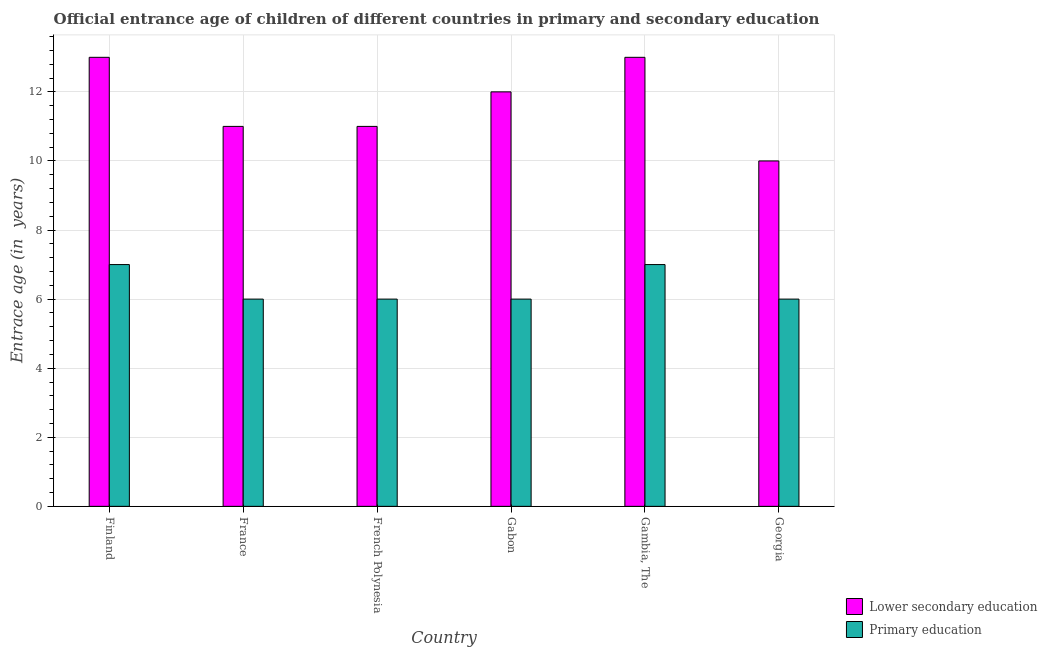How many different coloured bars are there?
Give a very brief answer. 2. How many groups of bars are there?
Offer a terse response. 6. How many bars are there on the 6th tick from the right?
Give a very brief answer. 2. What is the label of the 6th group of bars from the left?
Your answer should be very brief. Georgia. In how many cases, is the number of bars for a given country not equal to the number of legend labels?
Make the answer very short. 0. What is the entrance age of chiildren in primary education in French Polynesia?
Give a very brief answer. 6. Across all countries, what is the maximum entrance age of children in lower secondary education?
Your response must be concise. 13. Across all countries, what is the minimum entrance age of children in lower secondary education?
Provide a short and direct response. 10. In which country was the entrance age of children in lower secondary education maximum?
Provide a succinct answer. Finland. In which country was the entrance age of chiildren in primary education minimum?
Offer a terse response. France. What is the total entrance age of chiildren in primary education in the graph?
Provide a succinct answer. 38. What is the difference between the entrance age of children in lower secondary education in France and that in Gabon?
Give a very brief answer. -1. What is the difference between the entrance age of chiildren in primary education in French Polynesia and the entrance age of children in lower secondary education in Gabon?
Provide a succinct answer. -6. What is the average entrance age of chiildren in primary education per country?
Make the answer very short. 6.33. What is the difference between the entrance age of chiildren in primary education and entrance age of children in lower secondary education in Gabon?
Ensure brevity in your answer.  -6. In how many countries, is the entrance age of children in lower secondary education greater than 2.8 years?
Offer a very short reply. 6. What is the ratio of the entrance age of chiildren in primary education in Gabon to that in Gambia, The?
Offer a very short reply. 0.86. Is the entrance age of chiildren in primary education in Gabon less than that in Georgia?
Give a very brief answer. No. Is the difference between the entrance age of chiildren in primary education in Finland and Gambia, The greater than the difference between the entrance age of children in lower secondary education in Finland and Gambia, The?
Ensure brevity in your answer.  No. What is the difference between the highest and the second highest entrance age of children in lower secondary education?
Your answer should be very brief. 0. What is the difference between the highest and the lowest entrance age of children in lower secondary education?
Your answer should be compact. 3. In how many countries, is the entrance age of chiildren in primary education greater than the average entrance age of chiildren in primary education taken over all countries?
Make the answer very short. 2. Is the sum of the entrance age of children in lower secondary education in Gambia, The and Georgia greater than the maximum entrance age of chiildren in primary education across all countries?
Give a very brief answer. Yes. What does the 1st bar from the left in Finland represents?
Make the answer very short. Lower secondary education. What does the 2nd bar from the right in France represents?
Ensure brevity in your answer.  Lower secondary education. Are all the bars in the graph horizontal?
Keep it short and to the point. No. How many countries are there in the graph?
Your answer should be compact. 6. Does the graph contain any zero values?
Make the answer very short. No. Where does the legend appear in the graph?
Ensure brevity in your answer.  Bottom right. How many legend labels are there?
Your answer should be very brief. 2. How are the legend labels stacked?
Your response must be concise. Vertical. What is the title of the graph?
Provide a succinct answer. Official entrance age of children of different countries in primary and secondary education. What is the label or title of the Y-axis?
Offer a very short reply. Entrace age (in  years). What is the Entrace age (in  years) in Lower secondary education in Finland?
Provide a succinct answer. 13. What is the Entrace age (in  years) in Primary education in Finland?
Provide a short and direct response. 7. What is the Entrace age (in  years) in Lower secondary education in France?
Ensure brevity in your answer.  11. What is the Entrace age (in  years) of Lower secondary education in French Polynesia?
Offer a terse response. 11. What is the Entrace age (in  years) of Lower secondary education in Gabon?
Keep it short and to the point. 12. What is the Entrace age (in  years) of Primary education in Gabon?
Your answer should be compact. 6. What is the Entrace age (in  years) of Primary education in Gambia, The?
Ensure brevity in your answer.  7. What is the Entrace age (in  years) in Lower secondary education in Georgia?
Give a very brief answer. 10. What is the Entrace age (in  years) in Primary education in Georgia?
Offer a terse response. 6. Across all countries, what is the maximum Entrace age (in  years) in Lower secondary education?
Ensure brevity in your answer.  13. Across all countries, what is the maximum Entrace age (in  years) in Primary education?
Offer a terse response. 7. Across all countries, what is the minimum Entrace age (in  years) in Lower secondary education?
Provide a short and direct response. 10. Across all countries, what is the minimum Entrace age (in  years) in Primary education?
Ensure brevity in your answer.  6. What is the total Entrace age (in  years) in Lower secondary education in the graph?
Your answer should be compact. 70. What is the difference between the Entrace age (in  years) of Lower secondary education in Finland and that in France?
Offer a terse response. 2. What is the difference between the Entrace age (in  years) in Primary education in Finland and that in France?
Offer a terse response. 1. What is the difference between the Entrace age (in  years) of Lower secondary education in Finland and that in French Polynesia?
Provide a succinct answer. 2. What is the difference between the Entrace age (in  years) in Lower secondary education in Finland and that in Gabon?
Give a very brief answer. 1. What is the difference between the Entrace age (in  years) of Lower secondary education in Finland and that in Georgia?
Your answer should be compact. 3. What is the difference between the Entrace age (in  years) in Primary education in France and that in French Polynesia?
Offer a very short reply. 0. What is the difference between the Entrace age (in  years) in Lower secondary education in France and that in Gabon?
Your answer should be very brief. -1. What is the difference between the Entrace age (in  years) of Primary education in France and that in Gabon?
Ensure brevity in your answer.  0. What is the difference between the Entrace age (in  years) of Lower secondary education in France and that in Gambia, The?
Provide a succinct answer. -2. What is the difference between the Entrace age (in  years) of Primary education in France and that in Gambia, The?
Provide a succinct answer. -1. What is the difference between the Entrace age (in  years) of Lower secondary education in France and that in Georgia?
Provide a succinct answer. 1. What is the difference between the Entrace age (in  years) in Lower secondary education in French Polynesia and that in Gabon?
Keep it short and to the point. -1. What is the difference between the Entrace age (in  years) in Primary education in French Polynesia and that in Gabon?
Your response must be concise. 0. What is the difference between the Entrace age (in  years) of Lower secondary education in French Polynesia and that in Gambia, The?
Offer a terse response. -2. What is the difference between the Entrace age (in  years) in Primary education in French Polynesia and that in Gambia, The?
Your answer should be compact. -1. What is the difference between the Entrace age (in  years) of Primary education in French Polynesia and that in Georgia?
Your answer should be compact. 0. What is the difference between the Entrace age (in  years) in Lower secondary education in Gabon and that in Georgia?
Your answer should be compact. 2. What is the difference between the Entrace age (in  years) in Primary education in Gambia, The and that in Georgia?
Keep it short and to the point. 1. What is the difference between the Entrace age (in  years) in Lower secondary education in Finland and the Entrace age (in  years) in Primary education in France?
Give a very brief answer. 7. What is the difference between the Entrace age (in  years) of Lower secondary education in Finland and the Entrace age (in  years) of Primary education in French Polynesia?
Ensure brevity in your answer.  7. What is the difference between the Entrace age (in  years) in Lower secondary education in Finland and the Entrace age (in  years) in Primary education in Gabon?
Provide a succinct answer. 7. What is the difference between the Entrace age (in  years) in Lower secondary education in France and the Entrace age (in  years) in Primary education in French Polynesia?
Keep it short and to the point. 5. What is the difference between the Entrace age (in  years) in Lower secondary education in France and the Entrace age (in  years) in Primary education in Gambia, The?
Give a very brief answer. 4. What is the difference between the Entrace age (in  years) of Lower secondary education in France and the Entrace age (in  years) of Primary education in Georgia?
Offer a very short reply. 5. What is the difference between the Entrace age (in  years) in Lower secondary education in French Polynesia and the Entrace age (in  years) in Primary education in Gambia, The?
Make the answer very short. 4. What is the average Entrace age (in  years) of Lower secondary education per country?
Your response must be concise. 11.67. What is the average Entrace age (in  years) in Primary education per country?
Your answer should be very brief. 6.33. What is the difference between the Entrace age (in  years) in Lower secondary education and Entrace age (in  years) in Primary education in Finland?
Offer a terse response. 6. What is the ratio of the Entrace age (in  years) in Lower secondary education in Finland to that in France?
Offer a terse response. 1.18. What is the ratio of the Entrace age (in  years) in Primary education in Finland to that in France?
Ensure brevity in your answer.  1.17. What is the ratio of the Entrace age (in  years) in Lower secondary education in Finland to that in French Polynesia?
Provide a succinct answer. 1.18. What is the ratio of the Entrace age (in  years) of Primary education in Finland to that in French Polynesia?
Your answer should be very brief. 1.17. What is the ratio of the Entrace age (in  years) of Lower secondary education in Finland to that in Gabon?
Keep it short and to the point. 1.08. What is the ratio of the Entrace age (in  years) in Primary education in Finland to that in Gabon?
Provide a succinct answer. 1.17. What is the ratio of the Entrace age (in  years) in Lower secondary education in Finland to that in Georgia?
Provide a short and direct response. 1.3. What is the ratio of the Entrace age (in  years) in Primary education in France to that in French Polynesia?
Your answer should be very brief. 1. What is the ratio of the Entrace age (in  years) of Primary education in France to that in Gabon?
Offer a very short reply. 1. What is the ratio of the Entrace age (in  years) of Lower secondary education in France to that in Gambia, The?
Provide a short and direct response. 0.85. What is the ratio of the Entrace age (in  years) of Lower secondary education in France to that in Georgia?
Your answer should be very brief. 1.1. What is the ratio of the Entrace age (in  years) in Primary education in French Polynesia to that in Gabon?
Make the answer very short. 1. What is the ratio of the Entrace age (in  years) in Lower secondary education in French Polynesia to that in Gambia, The?
Keep it short and to the point. 0.85. What is the ratio of the Entrace age (in  years) in Primary education in French Polynesia to that in Gambia, The?
Give a very brief answer. 0.86. What is the ratio of the Entrace age (in  years) in Primary education in French Polynesia to that in Georgia?
Your response must be concise. 1. What is the ratio of the Entrace age (in  years) of Lower secondary education in Gabon to that in Gambia, The?
Provide a succinct answer. 0.92. What is the ratio of the Entrace age (in  years) of Primary education in Gabon to that in Gambia, The?
Provide a succinct answer. 0.86. What is the ratio of the Entrace age (in  years) of Lower secondary education in Gabon to that in Georgia?
Offer a terse response. 1.2. What is the ratio of the Entrace age (in  years) in Primary education in Gabon to that in Georgia?
Your answer should be very brief. 1. What is the ratio of the Entrace age (in  years) of Lower secondary education in Gambia, The to that in Georgia?
Keep it short and to the point. 1.3. What is the difference between the highest and the second highest Entrace age (in  years) in Lower secondary education?
Keep it short and to the point. 0. What is the difference between the highest and the second highest Entrace age (in  years) of Primary education?
Offer a very short reply. 0. What is the difference between the highest and the lowest Entrace age (in  years) in Primary education?
Your answer should be compact. 1. 